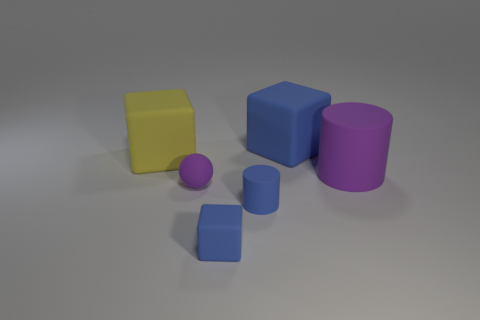Can you describe the lighting setup in this scene? The scene is illuminated with what appears to be soft, diffused lighting, probably simulating an overcast sky. There are no harsh shadows or bright highlights, which suggests the use of global illumination techniques within 3D rendering software, providing even lighting across all objects. 